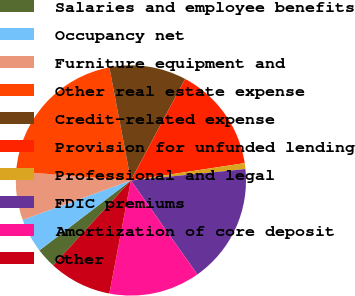<chart> <loc_0><loc_0><loc_500><loc_500><pie_chart><fcel>Salaries and employee benefits<fcel>Occupancy net<fcel>Furniture equipment and<fcel>Other real estate expense<fcel>Credit-related expense<fcel>Provision for unfunded lending<fcel>Professional and legal<fcel>FDIC premiums<fcel>Amortization of core deposit<fcel>Other<nl><fcel>2.82%<fcel>4.82%<fcel>6.81%<fcel>20.76%<fcel>10.8%<fcel>14.78%<fcel>0.83%<fcel>16.78%<fcel>12.79%<fcel>8.8%<nl></chart> 